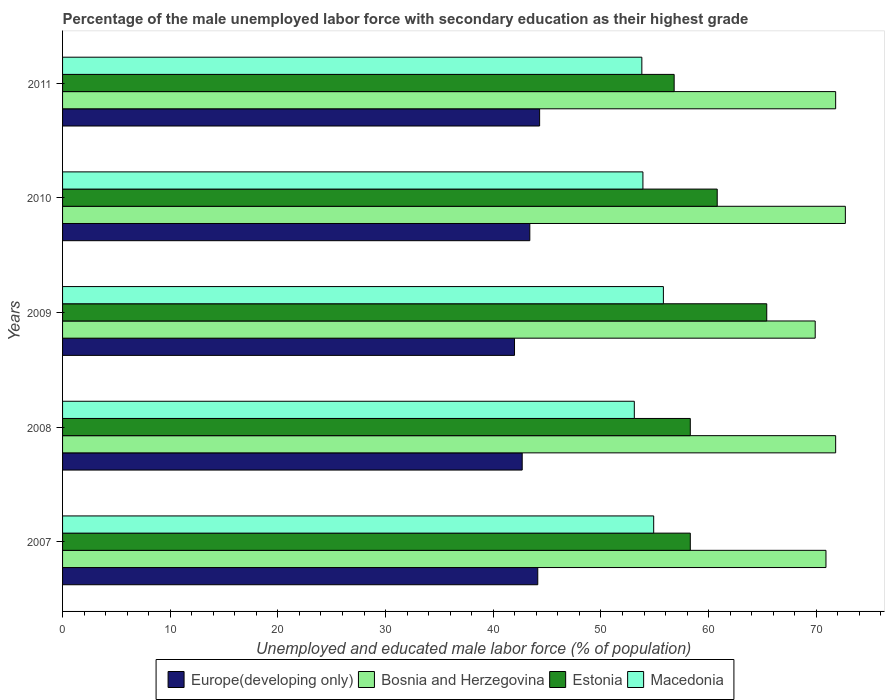How many groups of bars are there?
Provide a short and direct response. 5. How many bars are there on the 5th tick from the bottom?
Make the answer very short. 4. What is the label of the 1st group of bars from the top?
Offer a very short reply. 2011. In how many cases, is the number of bars for a given year not equal to the number of legend labels?
Ensure brevity in your answer.  0. What is the percentage of the unemployed male labor force with secondary education in Bosnia and Herzegovina in 2007?
Offer a very short reply. 70.9. Across all years, what is the maximum percentage of the unemployed male labor force with secondary education in Estonia?
Provide a succinct answer. 65.4. Across all years, what is the minimum percentage of the unemployed male labor force with secondary education in Macedonia?
Make the answer very short. 53.1. In which year was the percentage of the unemployed male labor force with secondary education in Estonia maximum?
Provide a short and direct response. 2009. What is the total percentage of the unemployed male labor force with secondary education in Estonia in the graph?
Your response must be concise. 299.6. What is the difference between the percentage of the unemployed male labor force with secondary education in Macedonia in 2009 and that in 2011?
Offer a terse response. 2. What is the difference between the percentage of the unemployed male labor force with secondary education in Bosnia and Herzegovina in 2008 and the percentage of the unemployed male labor force with secondary education in Macedonia in 2007?
Offer a very short reply. 16.9. What is the average percentage of the unemployed male labor force with secondary education in Macedonia per year?
Provide a succinct answer. 54.3. In the year 2008, what is the difference between the percentage of the unemployed male labor force with secondary education in Bosnia and Herzegovina and percentage of the unemployed male labor force with secondary education in Europe(developing only)?
Your answer should be very brief. 29.11. In how many years, is the percentage of the unemployed male labor force with secondary education in Macedonia greater than 2 %?
Offer a terse response. 5. What is the ratio of the percentage of the unemployed male labor force with secondary education in Macedonia in 2007 to that in 2009?
Give a very brief answer. 0.98. What is the difference between the highest and the second highest percentage of the unemployed male labor force with secondary education in Europe(developing only)?
Ensure brevity in your answer.  0.17. What is the difference between the highest and the lowest percentage of the unemployed male labor force with secondary education in Macedonia?
Make the answer very short. 2.7. Is the sum of the percentage of the unemployed male labor force with secondary education in Europe(developing only) in 2008 and 2011 greater than the maximum percentage of the unemployed male labor force with secondary education in Macedonia across all years?
Your answer should be very brief. Yes. What does the 3rd bar from the top in 2007 represents?
Your answer should be very brief. Bosnia and Herzegovina. What does the 4th bar from the bottom in 2008 represents?
Offer a terse response. Macedonia. Is it the case that in every year, the sum of the percentage of the unemployed male labor force with secondary education in Europe(developing only) and percentage of the unemployed male labor force with secondary education in Bosnia and Herzegovina is greater than the percentage of the unemployed male labor force with secondary education in Estonia?
Give a very brief answer. Yes. How many bars are there?
Provide a short and direct response. 20. Are all the bars in the graph horizontal?
Offer a very short reply. Yes. How many years are there in the graph?
Keep it short and to the point. 5. What is the difference between two consecutive major ticks on the X-axis?
Provide a short and direct response. 10. Does the graph contain any zero values?
Offer a very short reply. No. How many legend labels are there?
Provide a succinct answer. 4. What is the title of the graph?
Offer a very short reply. Percentage of the male unemployed labor force with secondary education as their highest grade. What is the label or title of the X-axis?
Offer a very short reply. Unemployed and educated male labor force (% of population). What is the label or title of the Y-axis?
Your answer should be compact. Years. What is the Unemployed and educated male labor force (% of population) in Europe(developing only) in 2007?
Make the answer very short. 44.13. What is the Unemployed and educated male labor force (% of population) of Bosnia and Herzegovina in 2007?
Offer a very short reply. 70.9. What is the Unemployed and educated male labor force (% of population) in Estonia in 2007?
Your response must be concise. 58.3. What is the Unemployed and educated male labor force (% of population) in Macedonia in 2007?
Make the answer very short. 54.9. What is the Unemployed and educated male labor force (% of population) in Europe(developing only) in 2008?
Offer a very short reply. 42.69. What is the Unemployed and educated male labor force (% of population) of Bosnia and Herzegovina in 2008?
Provide a short and direct response. 71.8. What is the Unemployed and educated male labor force (% of population) of Estonia in 2008?
Provide a short and direct response. 58.3. What is the Unemployed and educated male labor force (% of population) of Macedonia in 2008?
Give a very brief answer. 53.1. What is the Unemployed and educated male labor force (% of population) of Europe(developing only) in 2009?
Provide a short and direct response. 41.97. What is the Unemployed and educated male labor force (% of population) of Bosnia and Herzegovina in 2009?
Your response must be concise. 69.9. What is the Unemployed and educated male labor force (% of population) of Estonia in 2009?
Your response must be concise. 65.4. What is the Unemployed and educated male labor force (% of population) of Macedonia in 2009?
Offer a very short reply. 55.8. What is the Unemployed and educated male labor force (% of population) in Europe(developing only) in 2010?
Make the answer very short. 43.39. What is the Unemployed and educated male labor force (% of population) in Bosnia and Herzegovina in 2010?
Your response must be concise. 72.7. What is the Unemployed and educated male labor force (% of population) of Estonia in 2010?
Give a very brief answer. 60.8. What is the Unemployed and educated male labor force (% of population) in Macedonia in 2010?
Your response must be concise. 53.9. What is the Unemployed and educated male labor force (% of population) of Europe(developing only) in 2011?
Provide a short and direct response. 44.31. What is the Unemployed and educated male labor force (% of population) in Bosnia and Herzegovina in 2011?
Keep it short and to the point. 71.8. What is the Unemployed and educated male labor force (% of population) of Estonia in 2011?
Your response must be concise. 56.8. What is the Unemployed and educated male labor force (% of population) in Macedonia in 2011?
Ensure brevity in your answer.  53.8. Across all years, what is the maximum Unemployed and educated male labor force (% of population) in Europe(developing only)?
Your answer should be compact. 44.31. Across all years, what is the maximum Unemployed and educated male labor force (% of population) of Bosnia and Herzegovina?
Ensure brevity in your answer.  72.7. Across all years, what is the maximum Unemployed and educated male labor force (% of population) in Estonia?
Your answer should be compact. 65.4. Across all years, what is the maximum Unemployed and educated male labor force (% of population) of Macedonia?
Keep it short and to the point. 55.8. Across all years, what is the minimum Unemployed and educated male labor force (% of population) of Europe(developing only)?
Ensure brevity in your answer.  41.97. Across all years, what is the minimum Unemployed and educated male labor force (% of population) of Bosnia and Herzegovina?
Keep it short and to the point. 69.9. Across all years, what is the minimum Unemployed and educated male labor force (% of population) of Estonia?
Provide a succinct answer. 56.8. Across all years, what is the minimum Unemployed and educated male labor force (% of population) of Macedonia?
Your response must be concise. 53.1. What is the total Unemployed and educated male labor force (% of population) in Europe(developing only) in the graph?
Provide a short and direct response. 216.5. What is the total Unemployed and educated male labor force (% of population) of Bosnia and Herzegovina in the graph?
Make the answer very short. 357.1. What is the total Unemployed and educated male labor force (% of population) of Estonia in the graph?
Make the answer very short. 299.6. What is the total Unemployed and educated male labor force (% of population) in Macedonia in the graph?
Offer a very short reply. 271.5. What is the difference between the Unemployed and educated male labor force (% of population) in Europe(developing only) in 2007 and that in 2008?
Make the answer very short. 1.45. What is the difference between the Unemployed and educated male labor force (% of population) in Europe(developing only) in 2007 and that in 2009?
Your answer should be compact. 2.16. What is the difference between the Unemployed and educated male labor force (% of population) in Europe(developing only) in 2007 and that in 2010?
Offer a very short reply. 0.74. What is the difference between the Unemployed and educated male labor force (% of population) of Estonia in 2007 and that in 2010?
Give a very brief answer. -2.5. What is the difference between the Unemployed and educated male labor force (% of population) in Europe(developing only) in 2007 and that in 2011?
Your response must be concise. -0.17. What is the difference between the Unemployed and educated male labor force (% of population) of Bosnia and Herzegovina in 2007 and that in 2011?
Make the answer very short. -0.9. What is the difference between the Unemployed and educated male labor force (% of population) in Europe(developing only) in 2008 and that in 2009?
Ensure brevity in your answer.  0.71. What is the difference between the Unemployed and educated male labor force (% of population) of Macedonia in 2008 and that in 2009?
Give a very brief answer. -2.7. What is the difference between the Unemployed and educated male labor force (% of population) of Europe(developing only) in 2008 and that in 2010?
Make the answer very short. -0.71. What is the difference between the Unemployed and educated male labor force (% of population) of Estonia in 2008 and that in 2010?
Ensure brevity in your answer.  -2.5. What is the difference between the Unemployed and educated male labor force (% of population) in Macedonia in 2008 and that in 2010?
Your answer should be very brief. -0.8. What is the difference between the Unemployed and educated male labor force (% of population) of Europe(developing only) in 2008 and that in 2011?
Ensure brevity in your answer.  -1.62. What is the difference between the Unemployed and educated male labor force (% of population) in Europe(developing only) in 2009 and that in 2010?
Your answer should be compact. -1.42. What is the difference between the Unemployed and educated male labor force (% of population) of Bosnia and Herzegovina in 2009 and that in 2010?
Provide a short and direct response. -2.8. What is the difference between the Unemployed and educated male labor force (% of population) in Europe(developing only) in 2009 and that in 2011?
Provide a short and direct response. -2.33. What is the difference between the Unemployed and educated male labor force (% of population) in Macedonia in 2009 and that in 2011?
Provide a short and direct response. 2. What is the difference between the Unemployed and educated male labor force (% of population) of Europe(developing only) in 2010 and that in 2011?
Give a very brief answer. -0.91. What is the difference between the Unemployed and educated male labor force (% of population) in Bosnia and Herzegovina in 2010 and that in 2011?
Your response must be concise. 0.9. What is the difference between the Unemployed and educated male labor force (% of population) of Estonia in 2010 and that in 2011?
Offer a very short reply. 4. What is the difference between the Unemployed and educated male labor force (% of population) of Europe(developing only) in 2007 and the Unemployed and educated male labor force (% of population) of Bosnia and Herzegovina in 2008?
Give a very brief answer. -27.67. What is the difference between the Unemployed and educated male labor force (% of population) of Europe(developing only) in 2007 and the Unemployed and educated male labor force (% of population) of Estonia in 2008?
Offer a very short reply. -14.17. What is the difference between the Unemployed and educated male labor force (% of population) of Europe(developing only) in 2007 and the Unemployed and educated male labor force (% of population) of Macedonia in 2008?
Your response must be concise. -8.97. What is the difference between the Unemployed and educated male labor force (% of population) in Europe(developing only) in 2007 and the Unemployed and educated male labor force (% of population) in Bosnia and Herzegovina in 2009?
Your response must be concise. -25.77. What is the difference between the Unemployed and educated male labor force (% of population) of Europe(developing only) in 2007 and the Unemployed and educated male labor force (% of population) of Estonia in 2009?
Make the answer very short. -21.27. What is the difference between the Unemployed and educated male labor force (% of population) of Europe(developing only) in 2007 and the Unemployed and educated male labor force (% of population) of Macedonia in 2009?
Keep it short and to the point. -11.67. What is the difference between the Unemployed and educated male labor force (% of population) of Bosnia and Herzegovina in 2007 and the Unemployed and educated male labor force (% of population) of Estonia in 2009?
Ensure brevity in your answer.  5.5. What is the difference between the Unemployed and educated male labor force (% of population) in Bosnia and Herzegovina in 2007 and the Unemployed and educated male labor force (% of population) in Macedonia in 2009?
Provide a short and direct response. 15.1. What is the difference between the Unemployed and educated male labor force (% of population) of Europe(developing only) in 2007 and the Unemployed and educated male labor force (% of population) of Bosnia and Herzegovina in 2010?
Provide a short and direct response. -28.57. What is the difference between the Unemployed and educated male labor force (% of population) of Europe(developing only) in 2007 and the Unemployed and educated male labor force (% of population) of Estonia in 2010?
Your answer should be compact. -16.67. What is the difference between the Unemployed and educated male labor force (% of population) in Europe(developing only) in 2007 and the Unemployed and educated male labor force (% of population) in Macedonia in 2010?
Keep it short and to the point. -9.77. What is the difference between the Unemployed and educated male labor force (% of population) in Bosnia and Herzegovina in 2007 and the Unemployed and educated male labor force (% of population) in Macedonia in 2010?
Offer a very short reply. 17. What is the difference between the Unemployed and educated male labor force (% of population) of Estonia in 2007 and the Unemployed and educated male labor force (% of population) of Macedonia in 2010?
Your answer should be very brief. 4.4. What is the difference between the Unemployed and educated male labor force (% of population) of Europe(developing only) in 2007 and the Unemployed and educated male labor force (% of population) of Bosnia and Herzegovina in 2011?
Make the answer very short. -27.67. What is the difference between the Unemployed and educated male labor force (% of population) in Europe(developing only) in 2007 and the Unemployed and educated male labor force (% of population) in Estonia in 2011?
Provide a short and direct response. -12.67. What is the difference between the Unemployed and educated male labor force (% of population) of Europe(developing only) in 2007 and the Unemployed and educated male labor force (% of population) of Macedonia in 2011?
Your answer should be very brief. -9.67. What is the difference between the Unemployed and educated male labor force (% of population) in Bosnia and Herzegovina in 2007 and the Unemployed and educated male labor force (% of population) in Estonia in 2011?
Keep it short and to the point. 14.1. What is the difference between the Unemployed and educated male labor force (% of population) in Bosnia and Herzegovina in 2007 and the Unemployed and educated male labor force (% of population) in Macedonia in 2011?
Your answer should be compact. 17.1. What is the difference between the Unemployed and educated male labor force (% of population) in Estonia in 2007 and the Unemployed and educated male labor force (% of population) in Macedonia in 2011?
Your answer should be compact. 4.5. What is the difference between the Unemployed and educated male labor force (% of population) in Europe(developing only) in 2008 and the Unemployed and educated male labor force (% of population) in Bosnia and Herzegovina in 2009?
Give a very brief answer. -27.21. What is the difference between the Unemployed and educated male labor force (% of population) in Europe(developing only) in 2008 and the Unemployed and educated male labor force (% of population) in Estonia in 2009?
Make the answer very short. -22.71. What is the difference between the Unemployed and educated male labor force (% of population) in Europe(developing only) in 2008 and the Unemployed and educated male labor force (% of population) in Macedonia in 2009?
Your answer should be compact. -13.11. What is the difference between the Unemployed and educated male labor force (% of population) in Bosnia and Herzegovina in 2008 and the Unemployed and educated male labor force (% of population) in Estonia in 2009?
Provide a succinct answer. 6.4. What is the difference between the Unemployed and educated male labor force (% of population) in Europe(developing only) in 2008 and the Unemployed and educated male labor force (% of population) in Bosnia and Herzegovina in 2010?
Your response must be concise. -30.01. What is the difference between the Unemployed and educated male labor force (% of population) in Europe(developing only) in 2008 and the Unemployed and educated male labor force (% of population) in Estonia in 2010?
Your answer should be very brief. -18.11. What is the difference between the Unemployed and educated male labor force (% of population) of Europe(developing only) in 2008 and the Unemployed and educated male labor force (% of population) of Macedonia in 2010?
Keep it short and to the point. -11.21. What is the difference between the Unemployed and educated male labor force (% of population) in Bosnia and Herzegovina in 2008 and the Unemployed and educated male labor force (% of population) in Macedonia in 2010?
Provide a succinct answer. 17.9. What is the difference between the Unemployed and educated male labor force (% of population) in Europe(developing only) in 2008 and the Unemployed and educated male labor force (% of population) in Bosnia and Herzegovina in 2011?
Give a very brief answer. -29.11. What is the difference between the Unemployed and educated male labor force (% of population) in Europe(developing only) in 2008 and the Unemployed and educated male labor force (% of population) in Estonia in 2011?
Keep it short and to the point. -14.11. What is the difference between the Unemployed and educated male labor force (% of population) in Europe(developing only) in 2008 and the Unemployed and educated male labor force (% of population) in Macedonia in 2011?
Give a very brief answer. -11.11. What is the difference between the Unemployed and educated male labor force (% of population) in Bosnia and Herzegovina in 2008 and the Unemployed and educated male labor force (% of population) in Estonia in 2011?
Ensure brevity in your answer.  15. What is the difference between the Unemployed and educated male labor force (% of population) in Bosnia and Herzegovina in 2008 and the Unemployed and educated male labor force (% of population) in Macedonia in 2011?
Ensure brevity in your answer.  18. What is the difference between the Unemployed and educated male labor force (% of population) in Estonia in 2008 and the Unemployed and educated male labor force (% of population) in Macedonia in 2011?
Your answer should be very brief. 4.5. What is the difference between the Unemployed and educated male labor force (% of population) of Europe(developing only) in 2009 and the Unemployed and educated male labor force (% of population) of Bosnia and Herzegovina in 2010?
Offer a terse response. -30.73. What is the difference between the Unemployed and educated male labor force (% of population) of Europe(developing only) in 2009 and the Unemployed and educated male labor force (% of population) of Estonia in 2010?
Your answer should be compact. -18.83. What is the difference between the Unemployed and educated male labor force (% of population) of Europe(developing only) in 2009 and the Unemployed and educated male labor force (% of population) of Macedonia in 2010?
Make the answer very short. -11.93. What is the difference between the Unemployed and educated male labor force (% of population) in Europe(developing only) in 2009 and the Unemployed and educated male labor force (% of population) in Bosnia and Herzegovina in 2011?
Provide a succinct answer. -29.83. What is the difference between the Unemployed and educated male labor force (% of population) in Europe(developing only) in 2009 and the Unemployed and educated male labor force (% of population) in Estonia in 2011?
Offer a terse response. -14.83. What is the difference between the Unemployed and educated male labor force (% of population) of Europe(developing only) in 2009 and the Unemployed and educated male labor force (% of population) of Macedonia in 2011?
Offer a very short reply. -11.83. What is the difference between the Unemployed and educated male labor force (% of population) in Bosnia and Herzegovina in 2009 and the Unemployed and educated male labor force (% of population) in Estonia in 2011?
Your answer should be very brief. 13.1. What is the difference between the Unemployed and educated male labor force (% of population) in Europe(developing only) in 2010 and the Unemployed and educated male labor force (% of population) in Bosnia and Herzegovina in 2011?
Your response must be concise. -28.41. What is the difference between the Unemployed and educated male labor force (% of population) in Europe(developing only) in 2010 and the Unemployed and educated male labor force (% of population) in Estonia in 2011?
Offer a very short reply. -13.41. What is the difference between the Unemployed and educated male labor force (% of population) in Europe(developing only) in 2010 and the Unemployed and educated male labor force (% of population) in Macedonia in 2011?
Give a very brief answer. -10.41. What is the difference between the Unemployed and educated male labor force (% of population) of Bosnia and Herzegovina in 2010 and the Unemployed and educated male labor force (% of population) of Estonia in 2011?
Make the answer very short. 15.9. What is the difference between the Unemployed and educated male labor force (% of population) of Bosnia and Herzegovina in 2010 and the Unemployed and educated male labor force (% of population) of Macedonia in 2011?
Your response must be concise. 18.9. What is the difference between the Unemployed and educated male labor force (% of population) in Estonia in 2010 and the Unemployed and educated male labor force (% of population) in Macedonia in 2011?
Offer a terse response. 7. What is the average Unemployed and educated male labor force (% of population) in Europe(developing only) per year?
Keep it short and to the point. 43.3. What is the average Unemployed and educated male labor force (% of population) of Bosnia and Herzegovina per year?
Ensure brevity in your answer.  71.42. What is the average Unemployed and educated male labor force (% of population) in Estonia per year?
Make the answer very short. 59.92. What is the average Unemployed and educated male labor force (% of population) of Macedonia per year?
Keep it short and to the point. 54.3. In the year 2007, what is the difference between the Unemployed and educated male labor force (% of population) of Europe(developing only) and Unemployed and educated male labor force (% of population) of Bosnia and Herzegovina?
Ensure brevity in your answer.  -26.77. In the year 2007, what is the difference between the Unemployed and educated male labor force (% of population) in Europe(developing only) and Unemployed and educated male labor force (% of population) in Estonia?
Your response must be concise. -14.17. In the year 2007, what is the difference between the Unemployed and educated male labor force (% of population) of Europe(developing only) and Unemployed and educated male labor force (% of population) of Macedonia?
Ensure brevity in your answer.  -10.77. In the year 2007, what is the difference between the Unemployed and educated male labor force (% of population) of Bosnia and Herzegovina and Unemployed and educated male labor force (% of population) of Macedonia?
Offer a terse response. 16. In the year 2008, what is the difference between the Unemployed and educated male labor force (% of population) in Europe(developing only) and Unemployed and educated male labor force (% of population) in Bosnia and Herzegovina?
Your answer should be very brief. -29.11. In the year 2008, what is the difference between the Unemployed and educated male labor force (% of population) of Europe(developing only) and Unemployed and educated male labor force (% of population) of Estonia?
Your answer should be very brief. -15.61. In the year 2008, what is the difference between the Unemployed and educated male labor force (% of population) in Europe(developing only) and Unemployed and educated male labor force (% of population) in Macedonia?
Ensure brevity in your answer.  -10.41. In the year 2008, what is the difference between the Unemployed and educated male labor force (% of population) in Bosnia and Herzegovina and Unemployed and educated male labor force (% of population) in Estonia?
Make the answer very short. 13.5. In the year 2008, what is the difference between the Unemployed and educated male labor force (% of population) of Bosnia and Herzegovina and Unemployed and educated male labor force (% of population) of Macedonia?
Your answer should be very brief. 18.7. In the year 2009, what is the difference between the Unemployed and educated male labor force (% of population) in Europe(developing only) and Unemployed and educated male labor force (% of population) in Bosnia and Herzegovina?
Offer a terse response. -27.93. In the year 2009, what is the difference between the Unemployed and educated male labor force (% of population) of Europe(developing only) and Unemployed and educated male labor force (% of population) of Estonia?
Your answer should be compact. -23.43. In the year 2009, what is the difference between the Unemployed and educated male labor force (% of population) of Europe(developing only) and Unemployed and educated male labor force (% of population) of Macedonia?
Keep it short and to the point. -13.83. In the year 2009, what is the difference between the Unemployed and educated male labor force (% of population) in Bosnia and Herzegovina and Unemployed and educated male labor force (% of population) in Estonia?
Offer a terse response. 4.5. In the year 2009, what is the difference between the Unemployed and educated male labor force (% of population) of Bosnia and Herzegovina and Unemployed and educated male labor force (% of population) of Macedonia?
Provide a succinct answer. 14.1. In the year 2010, what is the difference between the Unemployed and educated male labor force (% of population) in Europe(developing only) and Unemployed and educated male labor force (% of population) in Bosnia and Herzegovina?
Give a very brief answer. -29.31. In the year 2010, what is the difference between the Unemployed and educated male labor force (% of population) of Europe(developing only) and Unemployed and educated male labor force (% of population) of Estonia?
Provide a succinct answer. -17.41. In the year 2010, what is the difference between the Unemployed and educated male labor force (% of population) of Europe(developing only) and Unemployed and educated male labor force (% of population) of Macedonia?
Your response must be concise. -10.51. In the year 2010, what is the difference between the Unemployed and educated male labor force (% of population) in Bosnia and Herzegovina and Unemployed and educated male labor force (% of population) in Estonia?
Provide a short and direct response. 11.9. In the year 2010, what is the difference between the Unemployed and educated male labor force (% of population) of Bosnia and Herzegovina and Unemployed and educated male labor force (% of population) of Macedonia?
Your answer should be compact. 18.8. In the year 2010, what is the difference between the Unemployed and educated male labor force (% of population) of Estonia and Unemployed and educated male labor force (% of population) of Macedonia?
Your answer should be very brief. 6.9. In the year 2011, what is the difference between the Unemployed and educated male labor force (% of population) of Europe(developing only) and Unemployed and educated male labor force (% of population) of Bosnia and Herzegovina?
Your answer should be very brief. -27.49. In the year 2011, what is the difference between the Unemployed and educated male labor force (% of population) of Europe(developing only) and Unemployed and educated male labor force (% of population) of Estonia?
Make the answer very short. -12.49. In the year 2011, what is the difference between the Unemployed and educated male labor force (% of population) in Europe(developing only) and Unemployed and educated male labor force (% of population) in Macedonia?
Ensure brevity in your answer.  -9.49. What is the ratio of the Unemployed and educated male labor force (% of population) of Europe(developing only) in 2007 to that in 2008?
Offer a very short reply. 1.03. What is the ratio of the Unemployed and educated male labor force (% of population) of Bosnia and Herzegovina in 2007 to that in 2008?
Provide a short and direct response. 0.99. What is the ratio of the Unemployed and educated male labor force (% of population) in Macedonia in 2007 to that in 2008?
Your answer should be very brief. 1.03. What is the ratio of the Unemployed and educated male labor force (% of population) of Europe(developing only) in 2007 to that in 2009?
Your answer should be compact. 1.05. What is the ratio of the Unemployed and educated male labor force (% of population) in Bosnia and Herzegovina in 2007 to that in 2009?
Offer a terse response. 1.01. What is the ratio of the Unemployed and educated male labor force (% of population) in Estonia in 2007 to that in 2009?
Provide a short and direct response. 0.89. What is the ratio of the Unemployed and educated male labor force (% of population) in Macedonia in 2007 to that in 2009?
Give a very brief answer. 0.98. What is the ratio of the Unemployed and educated male labor force (% of population) of Bosnia and Herzegovina in 2007 to that in 2010?
Offer a terse response. 0.98. What is the ratio of the Unemployed and educated male labor force (% of population) in Estonia in 2007 to that in 2010?
Your response must be concise. 0.96. What is the ratio of the Unemployed and educated male labor force (% of population) of Macedonia in 2007 to that in 2010?
Make the answer very short. 1.02. What is the ratio of the Unemployed and educated male labor force (% of population) of Europe(developing only) in 2007 to that in 2011?
Make the answer very short. 1. What is the ratio of the Unemployed and educated male labor force (% of population) in Bosnia and Herzegovina in 2007 to that in 2011?
Your response must be concise. 0.99. What is the ratio of the Unemployed and educated male labor force (% of population) in Estonia in 2007 to that in 2011?
Make the answer very short. 1.03. What is the ratio of the Unemployed and educated male labor force (% of population) in Macedonia in 2007 to that in 2011?
Ensure brevity in your answer.  1.02. What is the ratio of the Unemployed and educated male labor force (% of population) in Bosnia and Herzegovina in 2008 to that in 2009?
Your answer should be compact. 1.03. What is the ratio of the Unemployed and educated male labor force (% of population) in Estonia in 2008 to that in 2009?
Your response must be concise. 0.89. What is the ratio of the Unemployed and educated male labor force (% of population) of Macedonia in 2008 to that in 2009?
Give a very brief answer. 0.95. What is the ratio of the Unemployed and educated male labor force (% of population) of Europe(developing only) in 2008 to that in 2010?
Your answer should be very brief. 0.98. What is the ratio of the Unemployed and educated male labor force (% of population) of Bosnia and Herzegovina in 2008 to that in 2010?
Your answer should be very brief. 0.99. What is the ratio of the Unemployed and educated male labor force (% of population) of Estonia in 2008 to that in 2010?
Offer a terse response. 0.96. What is the ratio of the Unemployed and educated male labor force (% of population) in Macedonia in 2008 to that in 2010?
Make the answer very short. 0.99. What is the ratio of the Unemployed and educated male labor force (% of population) of Europe(developing only) in 2008 to that in 2011?
Give a very brief answer. 0.96. What is the ratio of the Unemployed and educated male labor force (% of population) of Bosnia and Herzegovina in 2008 to that in 2011?
Your answer should be compact. 1. What is the ratio of the Unemployed and educated male labor force (% of population) in Estonia in 2008 to that in 2011?
Make the answer very short. 1.03. What is the ratio of the Unemployed and educated male labor force (% of population) in Macedonia in 2008 to that in 2011?
Offer a terse response. 0.99. What is the ratio of the Unemployed and educated male labor force (% of population) in Europe(developing only) in 2009 to that in 2010?
Keep it short and to the point. 0.97. What is the ratio of the Unemployed and educated male labor force (% of population) of Bosnia and Herzegovina in 2009 to that in 2010?
Your answer should be very brief. 0.96. What is the ratio of the Unemployed and educated male labor force (% of population) of Estonia in 2009 to that in 2010?
Give a very brief answer. 1.08. What is the ratio of the Unemployed and educated male labor force (% of population) of Macedonia in 2009 to that in 2010?
Offer a very short reply. 1.04. What is the ratio of the Unemployed and educated male labor force (% of population) in Bosnia and Herzegovina in 2009 to that in 2011?
Provide a succinct answer. 0.97. What is the ratio of the Unemployed and educated male labor force (% of population) of Estonia in 2009 to that in 2011?
Your answer should be compact. 1.15. What is the ratio of the Unemployed and educated male labor force (% of population) of Macedonia in 2009 to that in 2011?
Your answer should be compact. 1.04. What is the ratio of the Unemployed and educated male labor force (% of population) in Europe(developing only) in 2010 to that in 2011?
Provide a succinct answer. 0.98. What is the ratio of the Unemployed and educated male labor force (% of population) of Bosnia and Herzegovina in 2010 to that in 2011?
Provide a succinct answer. 1.01. What is the ratio of the Unemployed and educated male labor force (% of population) in Estonia in 2010 to that in 2011?
Provide a succinct answer. 1.07. What is the ratio of the Unemployed and educated male labor force (% of population) of Macedonia in 2010 to that in 2011?
Offer a terse response. 1. What is the difference between the highest and the second highest Unemployed and educated male labor force (% of population) in Europe(developing only)?
Keep it short and to the point. 0.17. What is the difference between the highest and the second highest Unemployed and educated male labor force (% of population) of Estonia?
Provide a short and direct response. 4.6. What is the difference between the highest and the second highest Unemployed and educated male labor force (% of population) in Macedonia?
Provide a succinct answer. 0.9. What is the difference between the highest and the lowest Unemployed and educated male labor force (% of population) of Europe(developing only)?
Your answer should be very brief. 2.33. What is the difference between the highest and the lowest Unemployed and educated male labor force (% of population) of Bosnia and Herzegovina?
Make the answer very short. 2.8. 